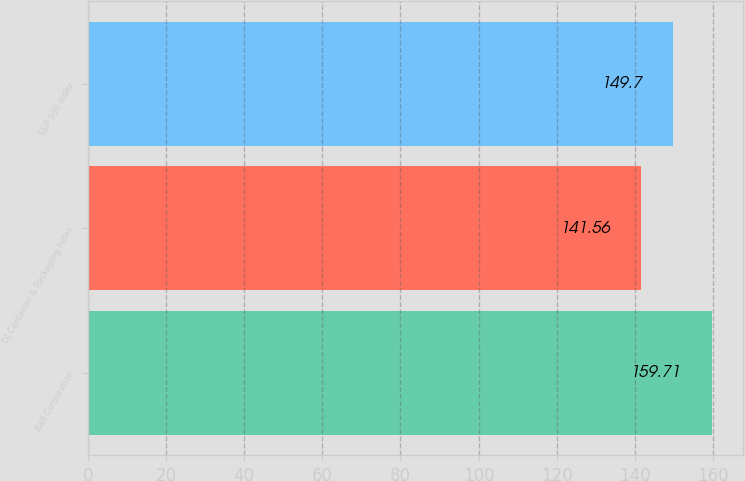Convert chart to OTSL. <chart><loc_0><loc_0><loc_500><loc_500><bar_chart><fcel>Ball Corporation<fcel>DJ Container & Packaging Index<fcel>S&P 500 Index<nl><fcel>159.71<fcel>141.56<fcel>149.7<nl></chart> 